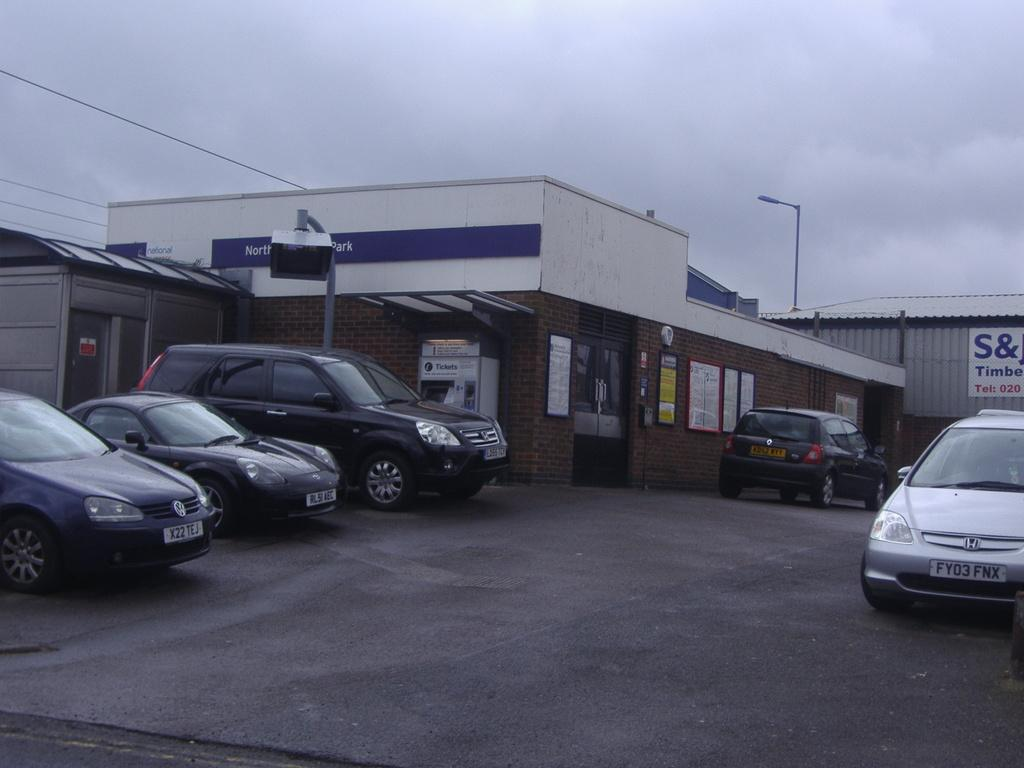What type of vehicles can be seen on the road in the image? There are motor vehicles on the road in the image. What structures are visible in the image? There are buildings, a street pole, a street light, and a shed in the image. What additional features can be seen in the image? There are advertisement boards and cables visible in the image. What is visible in the sky in the image? The sky is visible in the image, and clouds are present. Where is the cave located in the image? There is no cave present in the image. How many sons can be seen in the image? There are no sons visible in the image. 